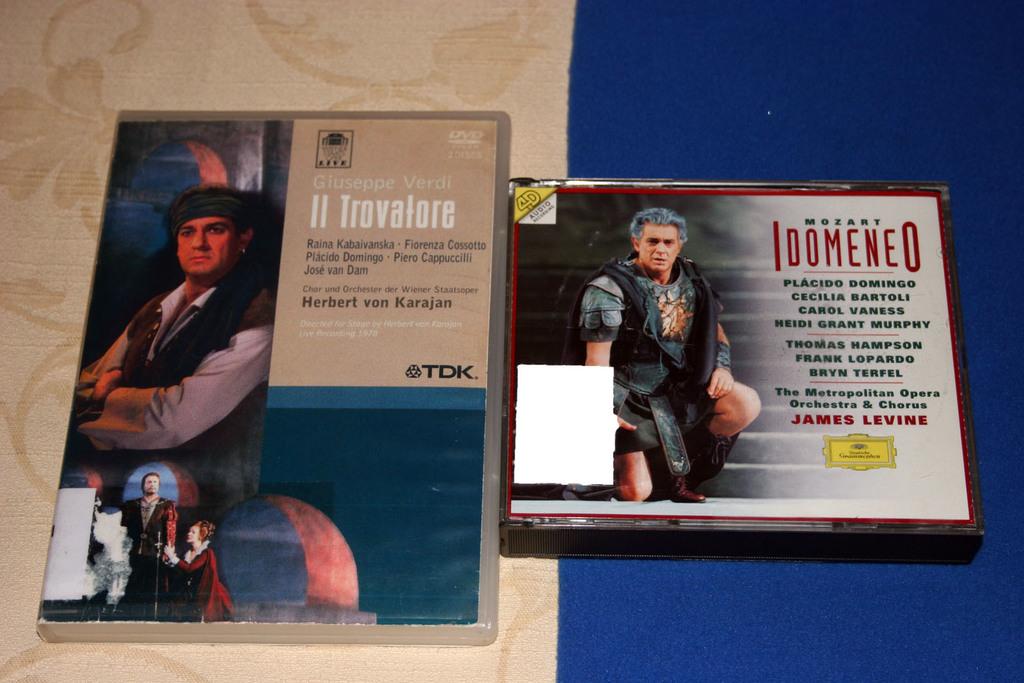This is book?
Your response must be concise. Answering does not require reading text in the image. 